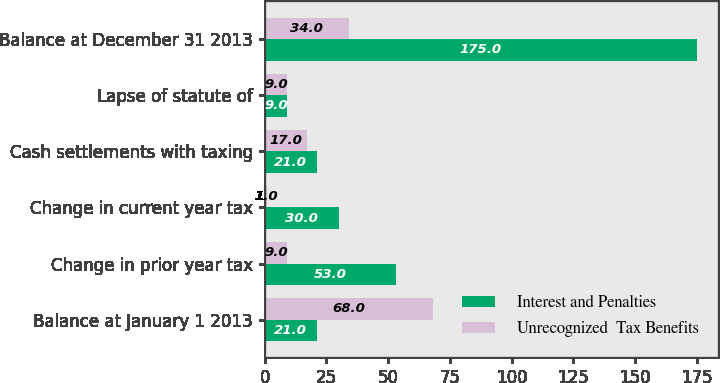Convert chart to OTSL. <chart><loc_0><loc_0><loc_500><loc_500><stacked_bar_chart><ecel><fcel>Balance at January 1 2013<fcel>Change in prior year tax<fcel>Change in current year tax<fcel>Cash settlements with taxing<fcel>Lapse of statute of<fcel>Balance at December 31 2013<nl><fcel>Interest and Penalties<fcel>21<fcel>53<fcel>30<fcel>21<fcel>9<fcel>175<nl><fcel>Unrecognized  Tax Benefits<fcel>68<fcel>9<fcel>1<fcel>17<fcel>9<fcel>34<nl></chart> 